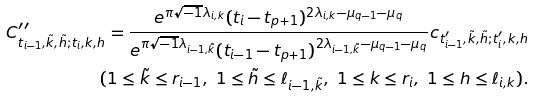<formula> <loc_0><loc_0><loc_500><loc_500>C ^ { \prime \prime } _ { t _ { i - 1 } , \tilde { k } , \tilde { h } ; t _ { i } , k , h } = \frac { e ^ { \pi \sqrt { - 1 } \lambda _ { i , k } } ( t _ { i } - t _ { p + 1 } ) ^ { 2 \lambda _ { i , k } - \mu _ { q - 1 } - \mu _ { q } } } { e ^ { \pi \sqrt { - 1 } \lambda _ { i - 1 , \tilde { k } } } ( t _ { i - 1 } - t _ { p + 1 } ) ^ { 2 \lambda _ { i - 1 , \tilde { k } } - \mu _ { q - 1 } - \mu _ { q } } } c _ { t ^ { \prime } _ { i - 1 } , \tilde { k } , \tilde { h } ; t ^ { \prime } _ { i } , k , h } \\ ( 1 \leq \tilde { k } \leq r _ { i - 1 } , \ 1 \leq \tilde { h } \leq \ell _ { i - 1 , \tilde { k } } , \ 1 \leq k \leq r _ { i } , \ 1 \leq h \leq \ell _ { i , k } ) .</formula> 